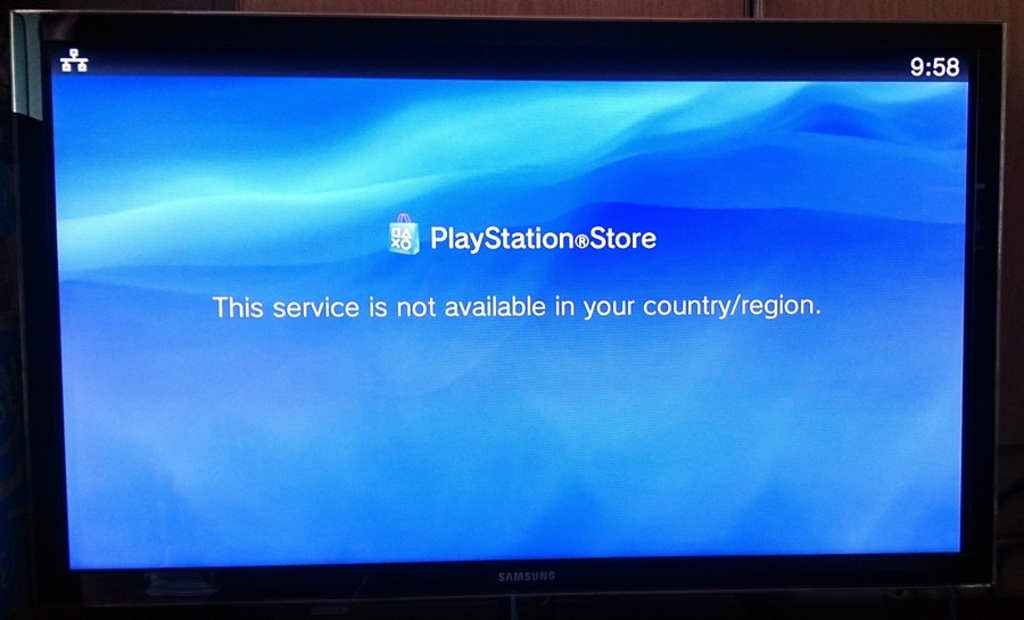Why might the PlayStation Store service be unavailable in this user's country or region? Services like the PlayStation Store may be unavailable in certain countries or regions due to a variety of reasons, including business decisions, licensing restrictions, regulatory issues, or local laws. Companies must navigate complex legal and economic landscapes when offering content globally, and sometimes, this can prevent them from providing services in particular locations. 